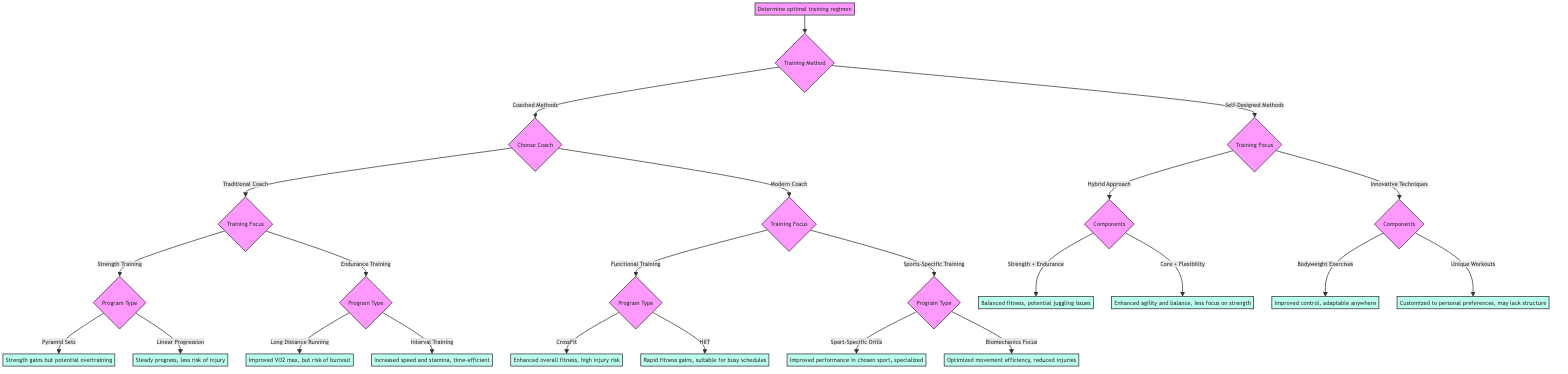What is the first decision point in the diagram? The first decision point is "Training Method", which branches into "Coached Methods" and "Self-Designed Methods".
Answer: Training Method How many options are available under "Choose Coach"? There are two options available under "Choose Coach": "Traditional Coach" and "Modern Coach".
Answer: 2 What outcome is associated with "HIIT"? The outcome associated with "HIIT" is "Rapid fitness gains, suitable for busy schedules."
Answer: Rapid fitness gains, suitable for busy schedules Which training focus leads to pyramid sets? "Strength Training" leads to "Pyramid Sets".
Answer: Strength Training What is the last node under "Innovative Techniques"? The last node under "Innovative Techniques" is "Unique Workouts".
Answer: Unique Workouts What is the primary training focus of "Modern Coach"? The primary training focuses of the "Modern Coach" are "Functional Training" and "Sports-Specific Training".
Answer: Functional Training and Sports-Specific Training Which node has the outcome indicating a risk of burnout? The node that has the outcome indicating a risk of burnout is "Long Distance Running".
Answer: Long Distance Running What are the two main components in the "Hybrid Approach"? The two main components are "Strength + Endurance" and "Core + Flexibility".
Answer: Strength + Endurance and Core + Flexibility What type of training is associated with "Strength gains but potential overtraining"? "Pyramid Sets" is associated with "Strength gains but potential overtraining".
Answer: Pyramid Sets 